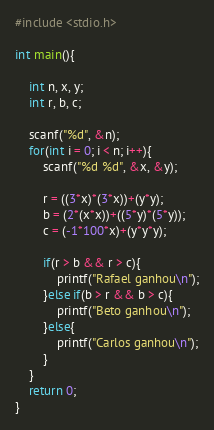Convert code to text. <code><loc_0><loc_0><loc_500><loc_500><_C++_>#include <stdio.h>

int main(){

    int n, x, y;
    int r, b, c;

    scanf("%d", &n);
    for(int i = 0; i < n; i++){
        scanf("%d %d", &x, &y);

        r = ((3*x)*(3*x))+(y*y);
        b = (2*(x*x))+((5*y)*(5*y));
        c = (-1*100*x)+(y*y*y);

        if(r > b && r > c){
            printf("Rafael ganhou\n");
        }else if(b > r && b > c){
            printf("Beto ganhou\n");
        }else{
            printf("Carlos ganhou\n");
        }
    }
    return 0;
}
</code> 